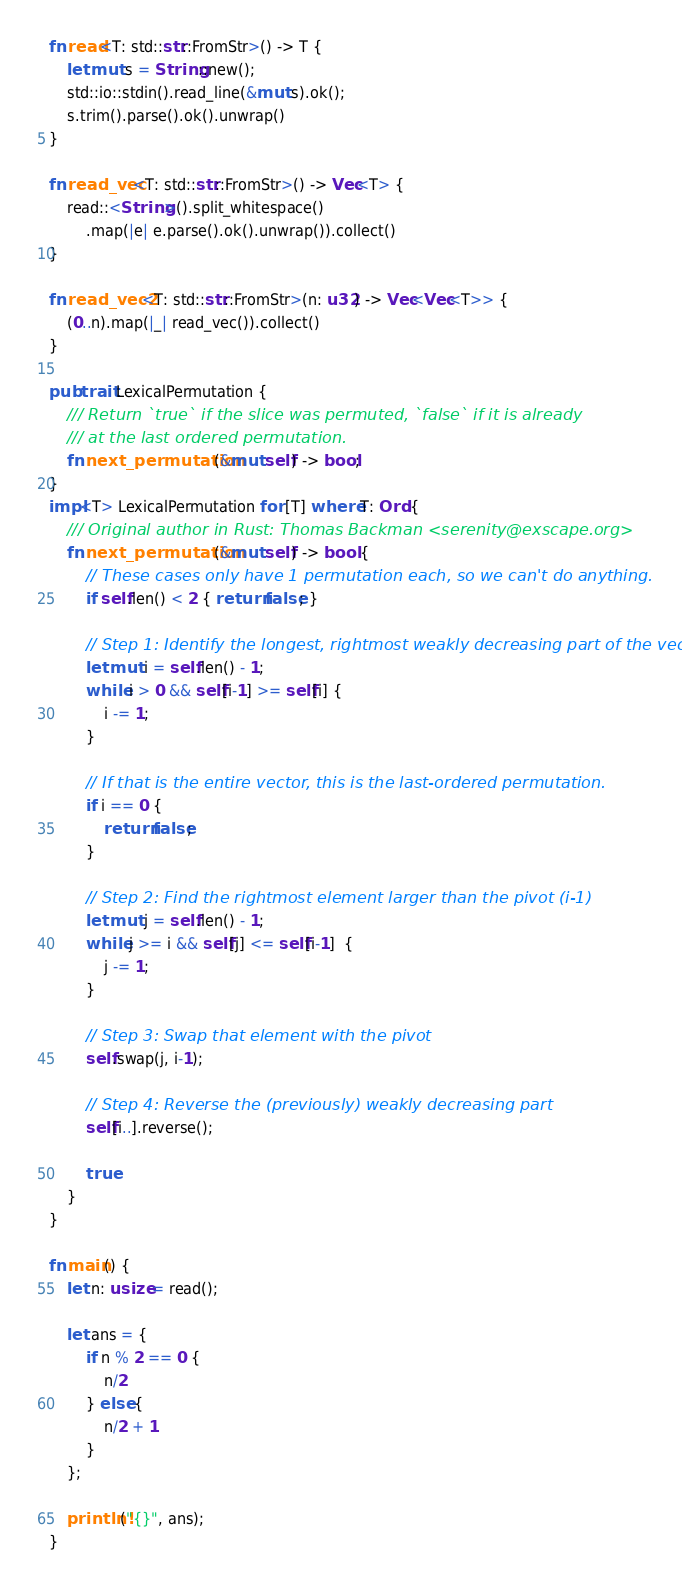<code> <loc_0><loc_0><loc_500><loc_500><_Rust_>fn read<T: std::str::FromStr>() -> T {
	let mut s = String::new();
	std::io::stdin().read_line(&mut s).ok();
	s.trim().parse().ok().unwrap()
}

fn read_vec<T: std::str::FromStr>() -> Vec<T> {
	read::<String>().split_whitespace()
		.map(|e| e.parse().ok().unwrap()).collect()
}

fn read_vec2<T: std::str::FromStr>(n: u32) -> Vec<Vec<T>> {
	(0..n).map(|_| read_vec()).collect()
}

pub trait LexicalPermutation {
	/// Return `true` if the slice was permuted, `false` if it is already
	/// at the last ordered permutation.
	fn next_permutation(&mut self) -> bool;
}
impl<T> LexicalPermutation for [T] where T: Ord {
	/// Original author in Rust: Thomas Backman <serenity@exscape.org>
	fn next_permutation(&mut self) -> bool {
		// These cases only have 1 permutation each, so we can't do anything.
		if self.len() < 2 { return false; }

		// Step 1: Identify the longest, rightmost weakly decreasing part of the vector
		let mut i = self.len() - 1;
		while i > 0 && self[i-1] >= self[i] {
			i -= 1;
		}

		// If that is the entire vector, this is the last-ordered permutation.
		if i == 0 {
			return false;
		}

		// Step 2: Find the rightmost element larger than the pivot (i-1)
		let mut j = self.len() - 1;
		while j >= i && self[j] <= self[i-1]  {
			j -= 1;
		}

		// Step 3: Swap that element with the pivot
		self.swap(j, i-1);

		// Step 4: Reverse the (previously) weakly decreasing part
		self[i..].reverse();

		true
	}
}

fn main() {
	let n: usize = read();

	let ans = {
		if n % 2 == 0 {
			n/2
		} else {
			n/2 + 1
		}
	};

	println!("{}", ans);
}
</code> 